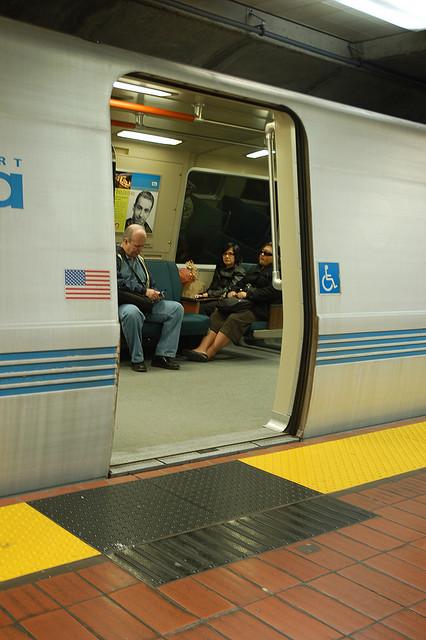Where is the bald man?
Give a very brief answer. On train. Is there a handicap sign?
Answer briefly. Yes. Is the train door closed?
Write a very short answer. No. 